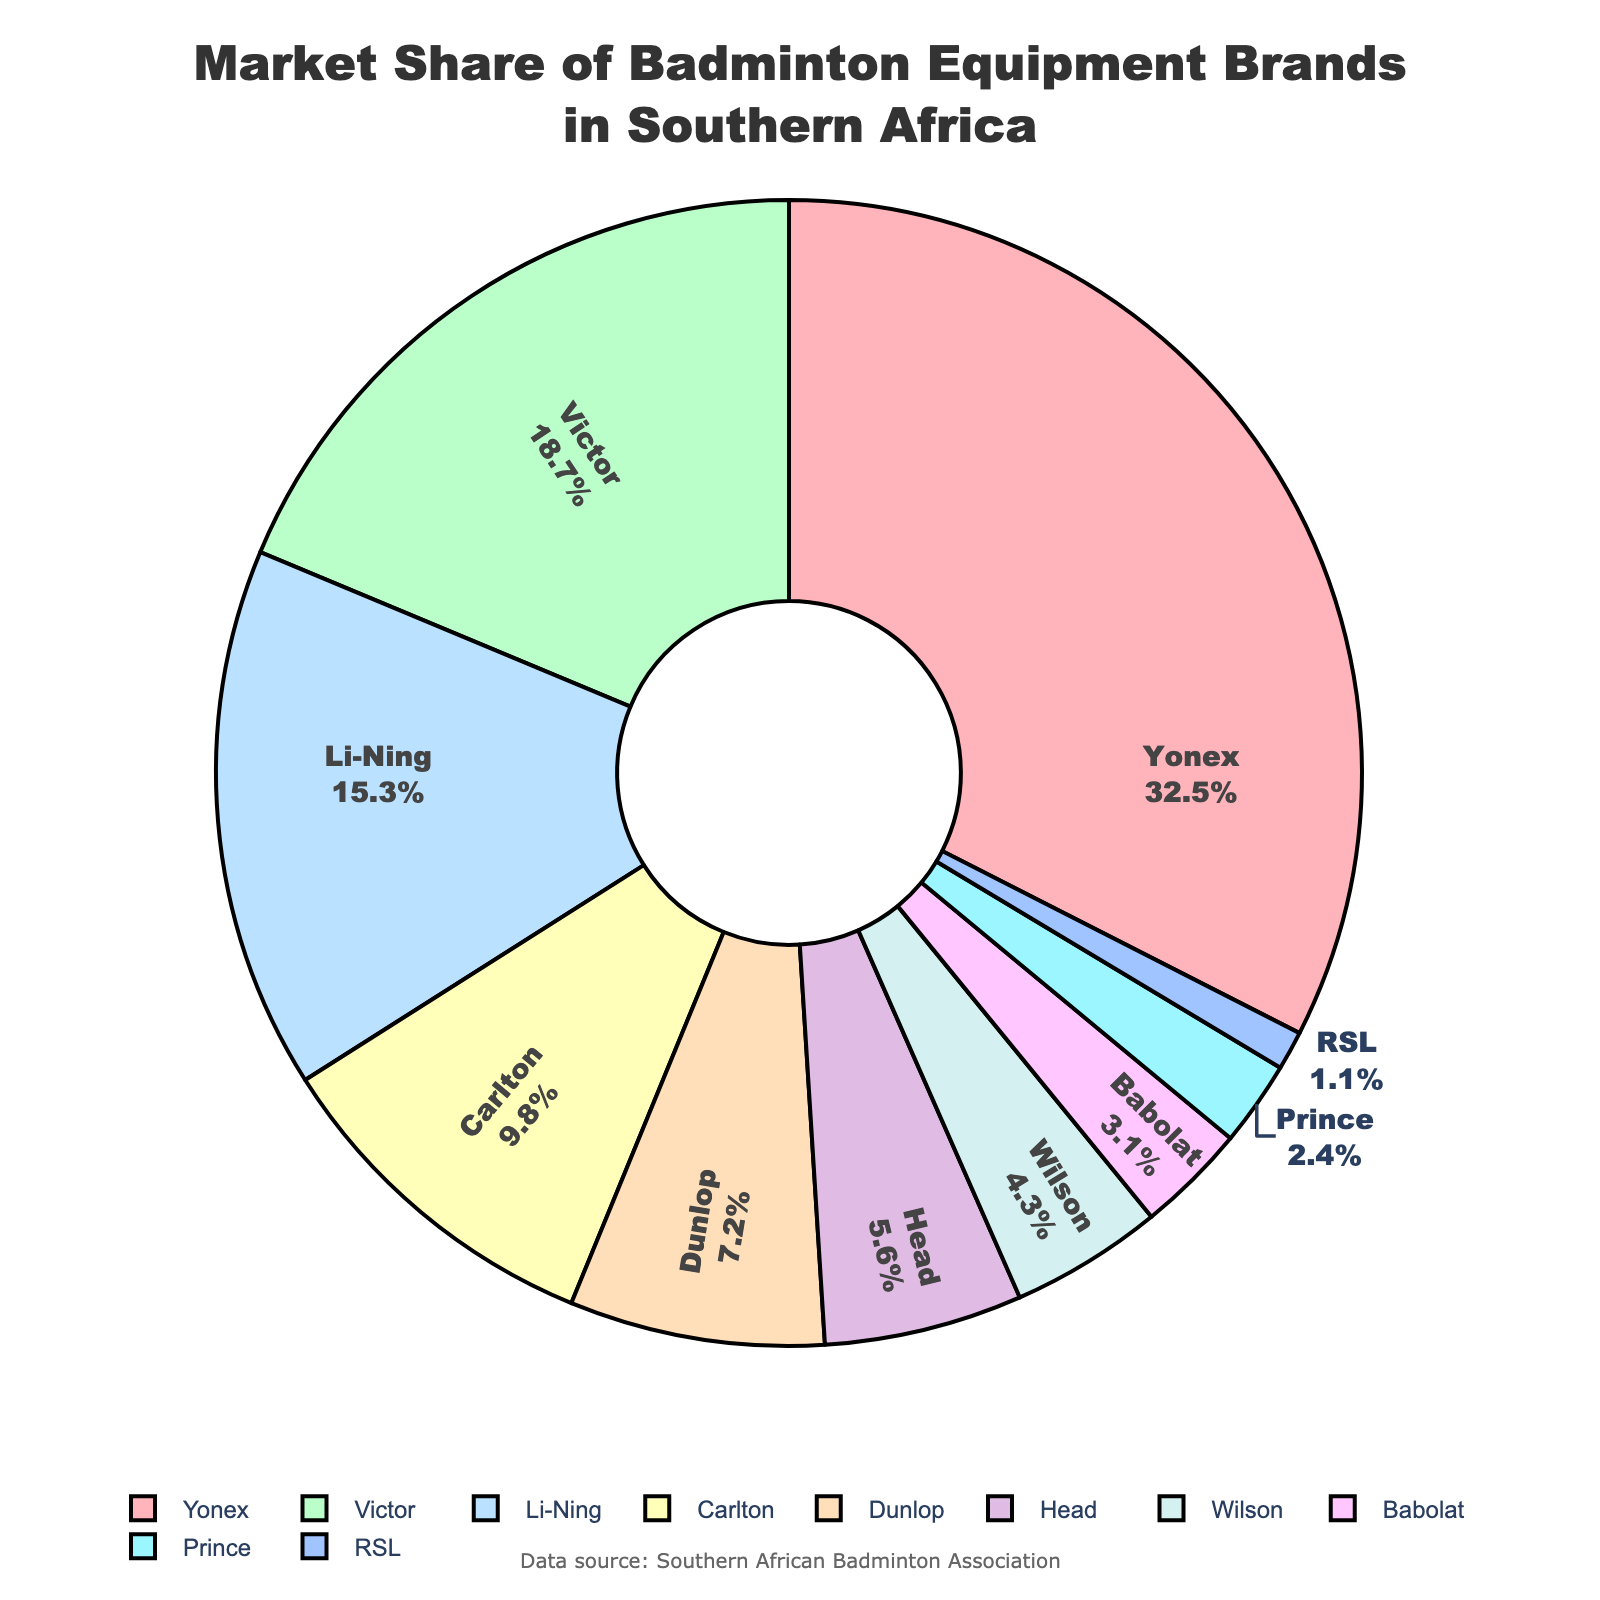What's the market share of the leading brand? The pie chart shows the market share for each brand. Yonex, having the largest portion, is identified as the leading brand with a market share of 32.5%.
Answer: 32.5% Which brands have a market share less than 5%? By examining the pie chart, we can identify that Head (5.6%) just exceeds 5%, while Wilson (4.3%), Babolat (3.1%), Prince (2.4%), and RSL (1.1%) all have a market share under 5%.
Answer: Wilson, Babolat, Prince, RSL What’s the combined market share of Victor and Li-Ning? Victor has a market share of 18.7% and Li-Ning has 15.3%. Adding these together, 18.7 + 15.3 = 34.
Answer: 34% Which brand has the second smallest market share and what is it? By ordering the brands by market share from smallest to largest, RSL has the smallest at 1.1%, and Prince has the second smallest at 2.4%.
Answer: Prince, 2.4% How many brands have a market share exceeding 10%? The pie chart indicates that Yonex (32.5%), Victor (18.7%), and Li-Ning (15.3%) all have market shares exceeding 10%. There are 3 brands in total.
Answer: 3 Is the market share of Carlton greater than the sum of Dunlop and Wilson? Carlton has 9.8%, Dunlop has 7.2%, and Wilson has 4.3%. The sum of Dunlop and Wilson is 7.2 + 4.3 = 11.5%, which is greater than Carlton's 9.8%.
Answer: No Which segment of the pie chart is represented by a blue color? The pie chart uses a range of colors, including shades of red, green, blue, etc., for different market segments. The blue segment represents Li-Ning.
Answer: Li-Ning If you combine the market shares of brands that make up less than 10%, what is the total market share? Brands with less than 10%: Dunlop (7.2%), Head (5.6%), Wilson (4.3%), Babolat (3.1%), Prince (2.4%), and RSL (1.1%). Their total is 7.2 + 5.6 + 4.3 + 3.1 + 2.4 + 1.1 = 23.7%.
Answer: 23.7% What is the difference in market share between the smallest and largest brands? Yonex is the largest at 32.5%, and RSL is the smallest at 1.1%. The difference is 32.5 - 1.1 = 31.4%.
Answer: 31.4% 